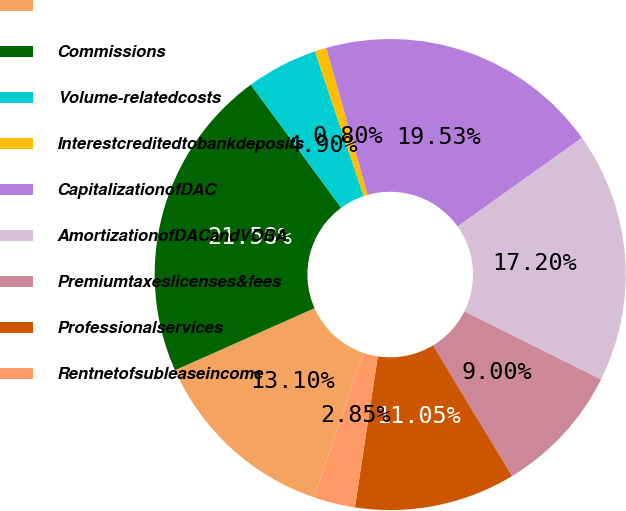<chart> <loc_0><loc_0><loc_500><loc_500><pie_chart><ecel><fcel>Commissions<fcel>Volume-relatedcosts<fcel>Interestcreditedtobankdeposits<fcel>CapitalizationofDAC<fcel>AmortizationofDACandVOBA<fcel>Premiumtaxeslicenses&fees<fcel>Professionalservices<fcel>Rentnetofsubleaseincome<nl><fcel>13.1%<fcel>21.58%<fcel>4.9%<fcel>0.8%<fcel>19.53%<fcel>17.2%<fcel>9.0%<fcel>11.05%<fcel>2.85%<nl></chart> 